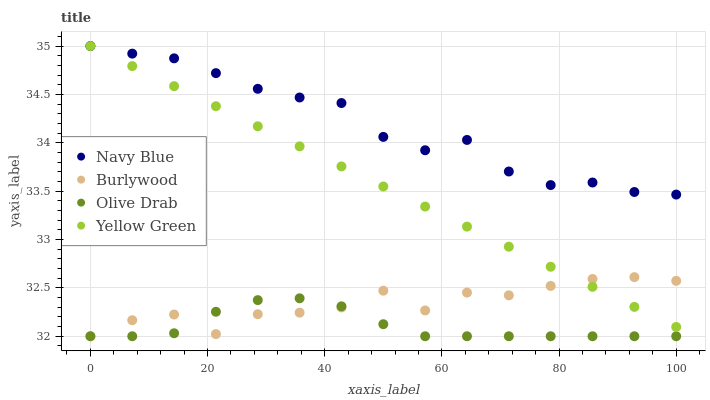Does Olive Drab have the minimum area under the curve?
Answer yes or no. Yes. Does Navy Blue have the maximum area under the curve?
Answer yes or no. Yes. Does Yellow Green have the minimum area under the curve?
Answer yes or no. No. Does Yellow Green have the maximum area under the curve?
Answer yes or no. No. Is Yellow Green the smoothest?
Answer yes or no. Yes. Is Burlywood the roughest?
Answer yes or no. Yes. Is Navy Blue the smoothest?
Answer yes or no. No. Is Navy Blue the roughest?
Answer yes or no. No. Does Burlywood have the lowest value?
Answer yes or no. Yes. Does Yellow Green have the lowest value?
Answer yes or no. No. Does Yellow Green have the highest value?
Answer yes or no. Yes. Does Olive Drab have the highest value?
Answer yes or no. No. Is Olive Drab less than Yellow Green?
Answer yes or no. Yes. Is Yellow Green greater than Olive Drab?
Answer yes or no. Yes. Does Yellow Green intersect Burlywood?
Answer yes or no. Yes. Is Yellow Green less than Burlywood?
Answer yes or no. No. Is Yellow Green greater than Burlywood?
Answer yes or no. No. Does Olive Drab intersect Yellow Green?
Answer yes or no. No. 